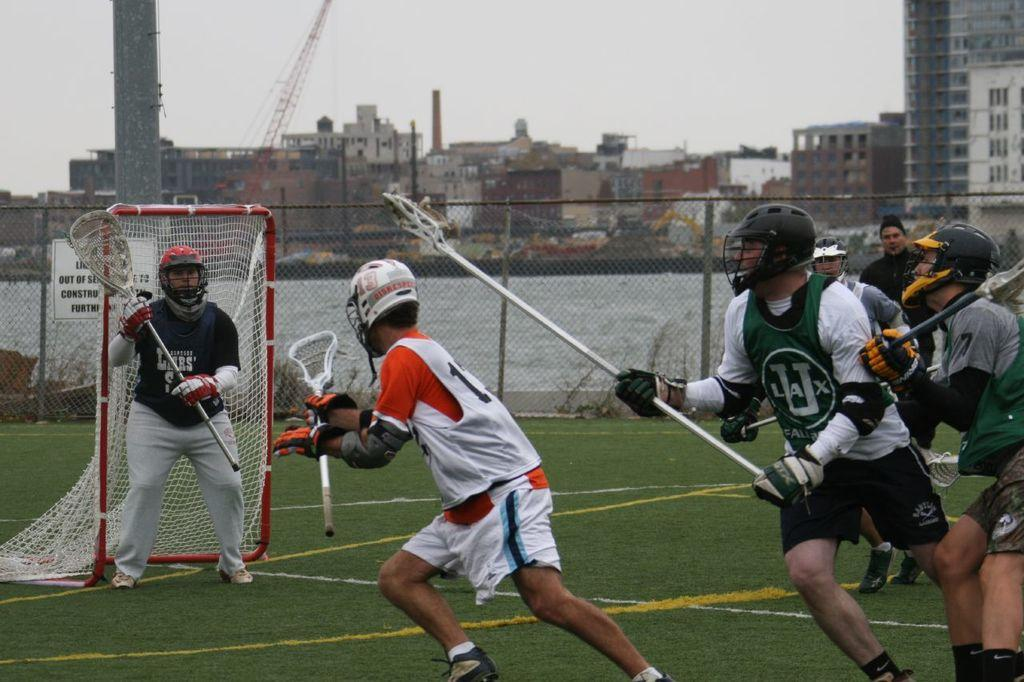Provide a one-sentence caption for the provided image. LaCrosse players are on a field with a sign behind them that informs of construction. 